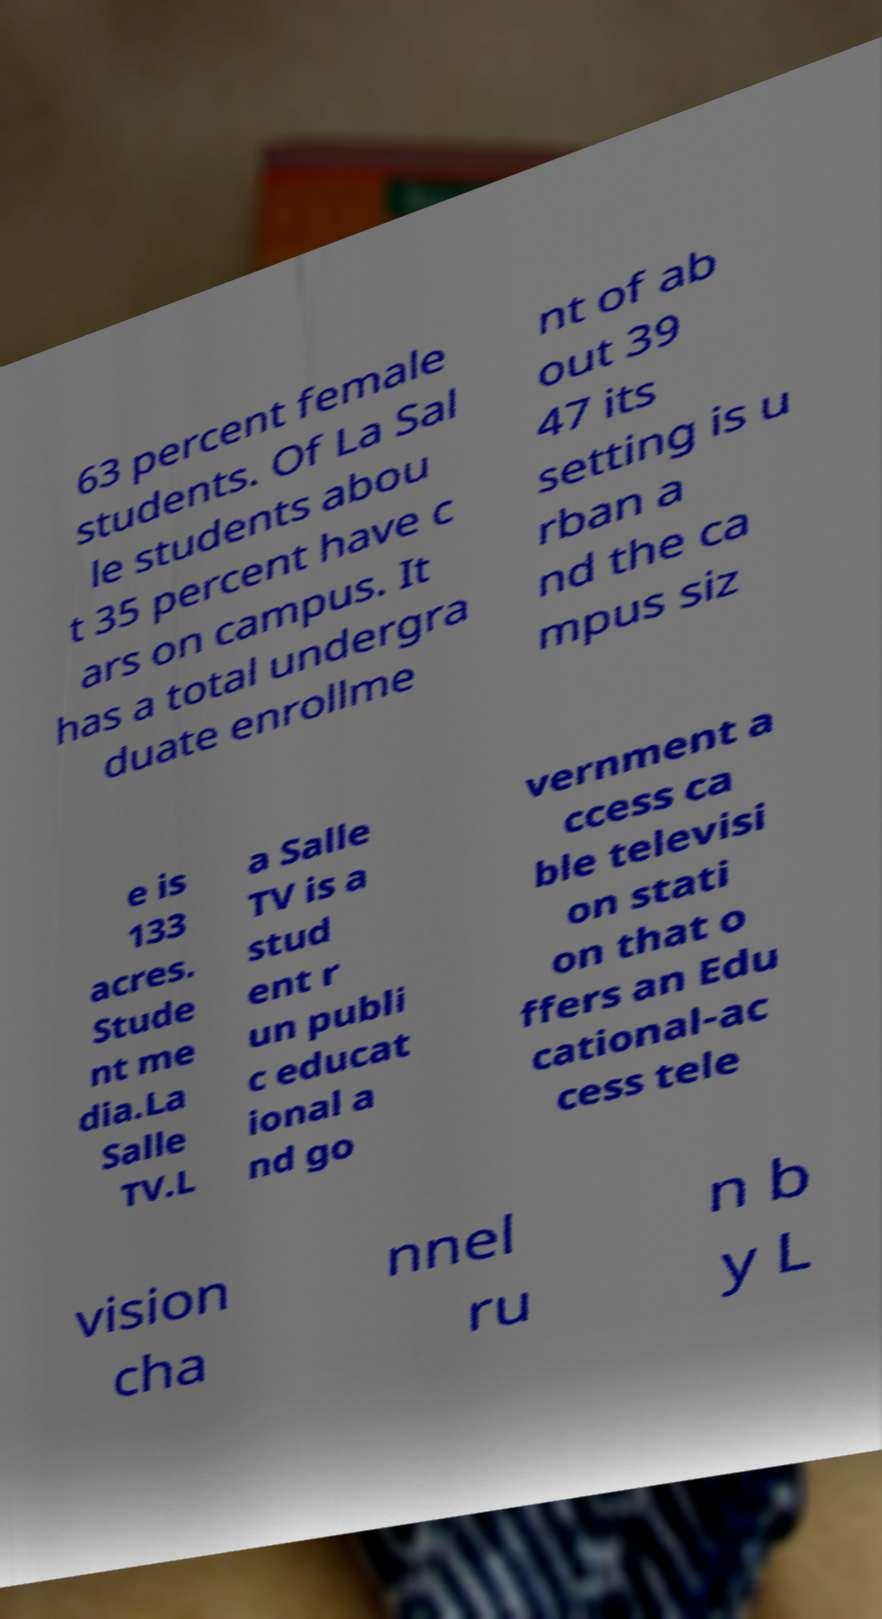What messages or text are displayed in this image? I need them in a readable, typed format. 63 percent female students. Of La Sal le students abou t 35 percent have c ars on campus. It has a total undergra duate enrollme nt of ab out 39 47 its setting is u rban a nd the ca mpus siz e is 133 acres. Stude nt me dia.La Salle TV.L a Salle TV is a stud ent r un publi c educat ional a nd go vernment a ccess ca ble televisi on stati on that o ffers an Edu cational-ac cess tele vision cha nnel ru n b y L 